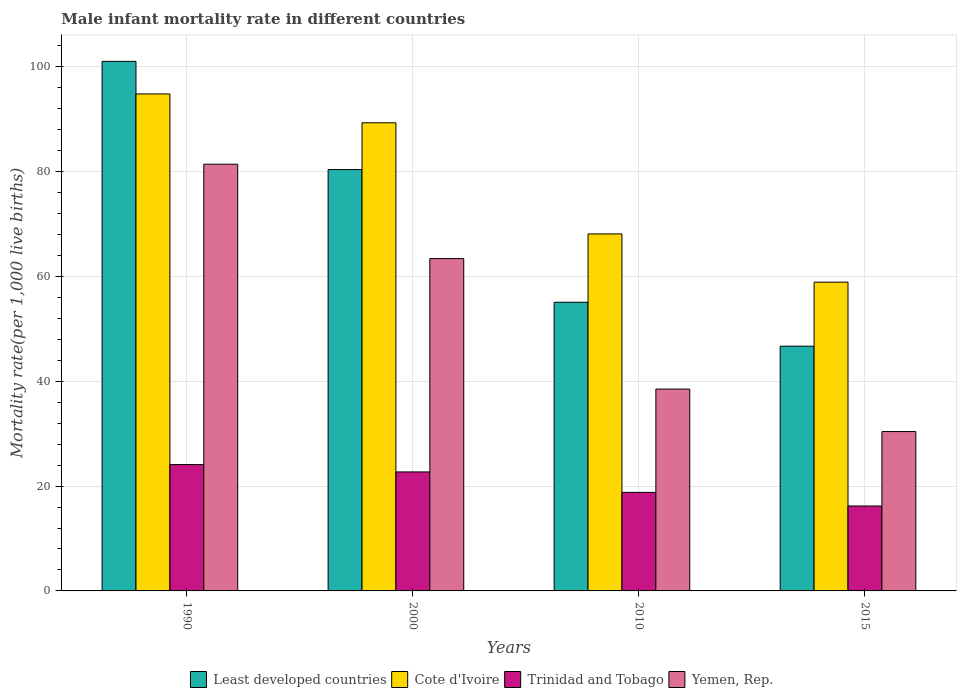How many different coloured bars are there?
Your response must be concise. 4. How many groups of bars are there?
Ensure brevity in your answer.  4. Are the number of bars per tick equal to the number of legend labels?
Your answer should be very brief. Yes. Are the number of bars on each tick of the X-axis equal?
Offer a very short reply. Yes. How many bars are there on the 4th tick from the right?
Give a very brief answer. 4. In how many cases, is the number of bars for a given year not equal to the number of legend labels?
Provide a short and direct response. 0. What is the male infant mortality rate in Cote d'Ivoire in 2010?
Your answer should be very brief. 68.1. Across all years, what is the maximum male infant mortality rate in Least developed countries?
Provide a short and direct response. 101.02. Across all years, what is the minimum male infant mortality rate in Cote d'Ivoire?
Provide a succinct answer. 58.9. In which year was the male infant mortality rate in Trinidad and Tobago maximum?
Offer a terse response. 1990. In which year was the male infant mortality rate in Yemen, Rep. minimum?
Ensure brevity in your answer.  2015. What is the total male infant mortality rate in Cote d'Ivoire in the graph?
Provide a succinct answer. 311.1. What is the difference between the male infant mortality rate in Trinidad and Tobago in 2000 and that in 2010?
Your answer should be compact. 3.9. What is the difference between the male infant mortality rate in Trinidad and Tobago in 2010 and the male infant mortality rate in Cote d'Ivoire in 2015?
Offer a terse response. -40.1. What is the average male infant mortality rate in Trinidad and Tobago per year?
Ensure brevity in your answer.  20.45. In the year 1990, what is the difference between the male infant mortality rate in Yemen, Rep. and male infant mortality rate in Trinidad and Tobago?
Offer a terse response. 57.3. In how many years, is the male infant mortality rate in Cote d'Ivoire greater than 64?
Keep it short and to the point. 3. What is the ratio of the male infant mortality rate in Least developed countries in 1990 to that in 2000?
Keep it short and to the point. 1.26. Is the difference between the male infant mortality rate in Yemen, Rep. in 2010 and 2015 greater than the difference between the male infant mortality rate in Trinidad and Tobago in 2010 and 2015?
Keep it short and to the point. Yes. What is the difference between the highest and the second highest male infant mortality rate in Trinidad and Tobago?
Your answer should be compact. 1.4. What is the difference between the highest and the lowest male infant mortality rate in Yemen, Rep.?
Offer a terse response. 51. Is the sum of the male infant mortality rate in Trinidad and Tobago in 2000 and 2015 greater than the maximum male infant mortality rate in Yemen, Rep. across all years?
Ensure brevity in your answer.  No. Is it the case that in every year, the sum of the male infant mortality rate in Yemen, Rep. and male infant mortality rate in Cote d'Ivoire is greater than the sum of male infant mortality rate in Least developed countries and male infant mortality rate in Trinidad and Tobago?
Offer a terse response. Yes. What does the 1st bar from the left in 2015 represents?
Make the answer very short. Least developed countries. What does the 1st bar from the right in 2015 represents?
Provide a short and direct response. Yemen, Rep. How many bars are there?
Your response must be concise. 16. Are all the bars in the graph horizontal?
Offer a terse response. No. How many years are there in the graph?
Provide a succinct answer. 4. What is the difference between two consecutive major ticks on the Y-axis?
Your answer should be compact. 20. Does the graph contain grids?
Provide a short and direct response. Yes. Where does the legend appear in the graph?
Your answer should be very brief. Bottom center. How are the legend labels stacked?
Offer a terse response. Horizontal. What is the title of the graph?
Your answer should be compact. Male infant mortality rate in different countries. Does "Zimbabwe" appear as one of the legend labels in the graph?
Offer a very short reply. No. What is the label or title of the Y-axis?
Provide a short and direct response. Mortality rate(per 1,0 live births). What is the Mortality rate(per 1,000 live births) of Least developed countries in 1990?
Keep it short and to the point. 101.02. What is the Mortality rate(per 1,000 live births) in Cote d'Ivoire in 1990?
Your answer should be very brief. 94.8. What is the Mortality rate(per 1,000 live births) in Trinidad and Tobago in 1990?
Provide a succinct answer. 24.1. What is the Mortality rate(per 1,000 live births) in Yemen, Rep. in 1990?
Your answer should be compact. 81.4. What is the Mortality rate(per 1,000 live births) of Least developed countries in 2000?
Your answer should be compact. 80.38. What is the Mortality rate(per 1,000 live births) in Cote d'Ivoire in 2000?
Make the answer very short. 89.3. What is the Mortality rate(per 1,000 live births) in Trinidad and Tobago in 2000?
Your answer should be compact. 22.7. What is the Mortality rate(per 1,000 live births) of Yemen, Rep. in 2000?
Give a very brief answer. 63.4. What is the Mortality rate(per 1,000 live births) of Least developed countries in 2010?
Ensure brevity in your answer.  55.07. What is the Mortality rate(per 1,000 live births) in Cote d'Ivoire in 2010?
Offer a terse response. 68.1. What is the Mortality rate(per 1,000 live births) in Yemen, Rep. in 2010?
Ensure brevity in your answer.  38.5. What is the Mortality rate(per 1,000 live births) of Least developed countries in 2015?
Give a very brief answer. 46.69. What is the Mortality rate(per 1,000 live births) of Cote d'Ivoire in 2015?
Provide a succinct answer. 58.9. What is the Mortality rate(per 1,000 live births) in Trinidad and Tobago in 2015?
Your answer should be very brief. 16.2. What is the Mortality rate(per 1,000 live births) of Yemen, Rep. in 2015?
Ensure brevity in your answer.  30.4. Across all years, what is the maximum Mortality rate(per 1,000 live births) in Least developed countries?
Give a very brief answer. 101.02. Across all years, what is the maximum Mortality rate(per 1,000 live births) of Cote d'Ivoire?
Provide a short and direct response. 94.8. Across all years, what is the maximum Mortality rate(per 1,000 live births) in Trinidad and Tobago?
Provide a succinct answer. 24.1. Across all years, what is the maximum Mortality rate(per 1,000 live births) in Yemen, Rep.?
Your response must be concise. 81.4. Across all years, what is the minimum Mortality rate(per 1,000 live births) in Least developed countries?
Give a very brief answer. 46.69. Across all years, what is the minimum Mortality rate(per 1,000 live births) in Cote d'Ivoire?
Your response must be concise. 58.9. Across all years, what is the minimum Mortality rate(per 1,000 live births) in Yemen, Rep.?
Keep it short and to the point. 30.4. What is the total Mortality rate(per 1,000 live births) in Least developed countries in the graph?
Offer a terse response. 283.15. What is the total Mortality rate(per 1,000 live births) in Cote d'Ivoire in the graph?
Your answer should be very brief. 311.1. What is the total Mortality rate(per 1,000 live births) in Trinidad and Tobago in the graph?
Provide a succinct answer. 81.8. What is the total Mortality rate(per 1,000 live births) in Yemen, Rep. in the graph?
Provide a succinct answer. 213.7. What is the difference between the Mortality rate(per 1,000 live births) in Least developed countries in 1990 and that in 2000?
Your response must be concise. 20.64. What is the difference between the Mortality rate(per 1,000 live births) in Trinidad and Tobago in 1990 and that in 2000?
Provide a short and direct response. 1.4. What is the difference between the Mortality rate(per 1,000 live births) in Least developed countries in 1990 and that in 2010?
Keep it short and to the point. 45.95. What is the difference between the Mortality rate(per 1,000 live births) of Cote d'Ivoire in 1990 and that in 2010?
Ensure brevity in your answer.  26.7. What is the difference between the Mortality rate(per 1,000 live births) in Trinidad and Tobago in 1990 and that in 2010?
Provide a succinct answer. 5.3. What is the difference between the Mortality rate(per 1,000 live births) in Yemen, Rep. in 1990 and that in 2010?
Ensure brevity in your answer.  42.9. What is the difference between the Mortality rate(per 1,000 live births) of Least developed countries in 1990 and that in 2015?
Keep it short and to the point. 54.33. What is the difference between the Mortality rate(per 1,000 live births) in Cote d'Ivoire in 1990 and that in 2015?
Provide a succinct answer. 35.9. What is the difference between the Mortality rate(per 1,000 live births) in Trinidad and Tobago in 1990 and that in 2015?
Ensure brevity in your answer.  7.9. What is the difference between the Mortality rate(per 1,000 live births) in Least developed countries in 2000 and that in 2010?
Make the answer very short. 25.31. What is the difference between the Mortality rate(per 1,000 live births) of Cote d'Ivoire in 2000 and that in 2010?
Ensure brevity in your answer.  21.2. What is the difference between the Mortality rate(per 1,000 live births) of Yemen, Rep. in 2000 and that in 2010?
Make the answer very short. 24.9. What is the difference between the Mortality rate(per 1,000 live births) of Least developed countries in 2000 and that in 2015?
Your answer should be very brief. 33.69. What is the difference between the Mortality rate(per 1,000 live births) of Cote d'Ivoire in 2000 and that in 2015?
Your answer should be compact. 30.4. What is the difference between the Mortality rate(per 1,000 live births) in Trinidad and Tobago in 2000 and that in 2015?
Ensure brevity in your answer.  6.5. What is the difference between the Mortality rate(per 1,000 live births) in Least developed countries in 2010 and that in 2015?
Give a very brief answer. 8.38. What is the difference between the Mortality rate(per 1,000 live births) of Cote d'Ivoire in 2010 and that in 2015?
Your answer should be compact. 9.2. What is the difference between the Mortality rate(per 1,000 live births) of Trinidad and Tobago in 2010 and that in 2015?
Your answer should be compact. 2.6. What is the difference between the Mortality rate(per 1,000 live births) in Least developed countries in 1990 and the Mortality rate(per 1,000 live births) in Cote d'Ivoire in 2000?
Provide a succinct answer. 11.72. What is the difference between the Mortality rate(per 1,000 live births) in Least developed countries in 1990 and the Mortality rate(per 1,000 live births) in Trinidad and Tobago in 2000?
Your answer should be very brief. 78.32. What is the difference between the Mortality rate(per 1,000 live births) in Least developed countries in 1990 and the Mortality rate(per 1,000 live births) in Yemen, Rep. in 2000?
Your answer should be very brief. 37.62. What is the difference between the Mortality rate(per 1,000 live births) in Cote d'Ivoire in 1990 and the Mortality rate(per 1,000 live births) in Trinidad and Tobago in 2000?
Ensure brevity in your answer.  72.1. What is the difference between the Mortality rate(per 1,000 live births) of Cote d'Ivoire in 1990 and the Mortality rate(per 1,000 live births) of Yemen, Rep. in 2000?
Give a very brief answer. 31.4. What is the difference between the Mortality rate(per 1,000 live births) of Trinidad and Tobago in 1990 and the Mortality rate(per 1,000 live births) of Yemen, Rep. in 2000?
Keep it short and to the point. -39.3. What is the difference between the Mortality rate(per 1,000 live births) of Least developed countries in 1990 and the Mortality rate(per 1,000 live births) of Cote d'Ivoire in 2010?
Provide a short and direct response. 32.92. What is the difference between the Mortality rate(per 1,000 live births) of Least developed countries in 1990 and the Mortality rate(per 1,000 live births) of Trinidad and Tobago in 2010?
Make the answer very short. 82.22. What is the difference between the Mortality rate(per 1,000 live births) of Least developed countries in 1990 and the Mortality rate(per 1,000 live births) of Yemen, Rep. in 2010?
Your response must be concise. 62.52. What is the difference between the Mortality rate(per 1,000 live births) in Cote d'Ivoire in 1990 and the Mortality rate(per 1,000 live births) in Trinidad and Tobago in 2010?
Provide a short and direct response. 76. What is the difference between the Mortality rate(per 1,000 live births) of Cote d'Ivoire in 1990 and the Mortality rate(per 1,000 live births) of Yemen, Rep. in 2010?
Your answer should be very brief. 56.3. What is the difference between the Mortality rate(per 1,000 live births) of Trinidad and Tobago in 1990 and the Mortality rate(per 1,000 live births) of Yemen, Rep. in 2010?
Give a very brief answer. -14.4. What is the difference between the Mortality rate(per 1,000 live births) of Least developed countries in 1990 and the Mortality rate(per 1,000 live births) of Cote d'Ivoire in 2015?
Provide a short and direct response. 42.12. What is the difference between the Mortality rate(per 1,000 live births) in Least developed countries in 1990 and the Mortality rate(per 1,000 live births) in Trinidad and Tobago in 2015?
Offer a terse response. 84.82. What is the difference between the Mortality rate(per 1,000 live births) of Least developed countries in 1990 and the Mortality rate(per 1,000 live births) of Yemen, Rep. in 2015?
Your answer should be very brief. 70.62. What is the difference between the Mortality rate(per 1,000 live births) of Cote d'Ivoire in 1990 and the Mortality rate(per 1,000 live births) of Trinidad and Tobago in 2015?
Offer a very short reply. 78.6. What is the difference between the Mortality rate(per 1,000 live births) in Cote d'Ivoire in 1990 and the Mortality rate(per 1,000 live births) in Yemen, Rep. in 2015?
Offer a terse response. 64.4. What is the difference between the Mortality rate(per 1,000 live births) of Least developed countries in 2000 and the Mortality rate(per 1,000 live births) of Cote d'Ivoire in 2010?
Your response must be concise. 12.28. What is the difference between the Mortality rate(per 1,000 live births) of Least developed countries in 2000 and the Mortality rate(per 1,000 live births) of Trinidad and Tobago in 2010?
Your response must be concise. 61.58. What is the difference between the Mortality rate(per 1,000 live births) of Least developed countries in 2000 and the Mortality rate(per 1,000 live births) of Yemen, Rep. in 2010?
Your answer should be very brief. 41.88. What is the difference between the Mortality rate(per 1,000 live births) of Cote d'Ivoire in 2000 and the Mortality rate(per 1,000 live births) of Trinidad and Tobago in 2010?
Make the answer very short. 70.5. What is the difference between the Mortality rate(per 1,000 live births) of Cote d'Ivoire in 2000 and the Mortality rate(per 1,000 live births) of Yemen, Rep. in 2010?
Offer a terse response. 50.8. What is the difference between the Mortality rate(per 1,000 live births) in Trinidad and Tobago in 2000 and the Mortality rate(per 1,000 live births) in Yemen, Rep. in 2010?
Give a very brief answer. -15.8. What is the difference between the Mortality rate(per 1,000 live births) in Least developed countries in 2000 and the Mortality rate(per 1,000 live births) in Cote d'Ivoire in 2015?
Offer a terse response. 21.48. What is the difference between the Mortality rate(per 1,000 live births) of Least developed countries in 2000 and the Mortality rate(per 1,000 live births) of Trinidad and Tobago in 2015?
Ensure brevity in your answer.  64.18. What is the difference between the Mortality rate(per 1,000 live births) of Least developed countries in 2000 and the Mortality rate(per 1,000 live births) of Yemen, Rep. in 2015?
Ensure brevity in your answer.  49.98. What is the difference between the Mortality rate(per 1,000 live births) of Cote d'Ivoire in 2000 and the Mortality rate(per 1,000 live births) of Trinidad and Tobago in 2015?
Give a very brief answer. 73.1. What is the difference between the Mortality rate(per 1,000 live births) of Cote d'Ivoire in 2000 and the Mortality rate(per 1,000 live births) of Yemen, Rep. in 2015?
Make the answer very short. 58.9. What is the difference between the Mortality rate(per 1,000 live births) of Trinidad and Tobago in 2000 and the Mortality rate(per 1,000 live births) of Yemen, Rep. in 2015?
Make the answer very short. -7.7. What is the difference between the Mortality rate(per 1,000 live births) in Least developed countries in 2010 and the Mortality rate(per 1,000 live births) in Cote d'Ivoire in 2015?
Keep it short and to the point. -3.83. What is the difference between the Mortality rate(per 1,000 live births) of Least developed countries in 2010 and the Mortality rate(per 1,000 live births) of Trinidad and Tobago in 2015?
Ensure brevity in your answer.  38.87. What is the difference between the Mortality rate(per 1,000 live births) in Least developed countries in 2010 and the Mortality rate(per 1,000 live births) in Yemen, Rep. in 2015?
Your answer should be very brief. 24.67. What is the difference between the Mortality rate(per 1,000 live births) in Cote d'Ivoire in 2010 and the Mortality rate(per 1,000 live births) in Trinidad and Tobago in 2015?
Make the answer very short. 51.9. What is the difference between the Mortality rate(per 1,000 live births) in Cote d'Ivoire in 2010 and the Mortality rate(per 1,000 live births) in Yemen, Rep. in 2015?
Your response must be concise. 37.7. What is the average Mortality rate(per 1,000 live births) of Least developed countries per year?
Provide a succinct answer. 70.79. What is the average Mortality rate(per 1,000 live births) of Cote d'Ivoire per year?
Your answer should be compact. 77.78. What is the average Mortality rate(per 1,000 live births) in Trinidad and Tobago per year?
Offer a very short reply. 20.45. What is the average Mortality rate(per 1,000 live births) in Yemen, Rep. per year?
Offer a terse response. 53.42. In the year 1990, what is the difference between the Mortality rate(per 1,000 live births) in Least developed countries and Mortality rate(per 1,000 live births) in Cote d'Ivoire?
Offer a terse response. 6.22. In the year 1990, what is the difference between the Mortality rate(per 1,000 live births) of Least developed countries and Mortality rate(per 1,000 live births) of Trinidad and Tobago?
Your answer should be compact. 76.92. In the year 1990, what is the difference between the Mortality rate(per 1,000 live births) of Least developed countries and Mortality rate(per 1,000 live births) of Yemen, Rep.?
Provide a short and direct response. 19.62. In the year 1990, what is the difference between the Mortality rate(per 1,000 live births) in Cote d'Ivoire and Mortality rate(per 1,000 live births) in Trinidad and Tobago?
Provide a succinct answer. 70.7. In the year 1990, what is the difference between the Mortality rate(per 1,000 live births) in Cote d'Ivoire and Mortality rate(per 1,000 live births) in Yemen, Rep.?
Provide a succinct answer. 13.4. In the year 1990, what is the difference between the Mortality rate(per 1,000 live births) in Trinidad and Tobago and Mortality rate(per 1,000 live births) in Yemen, Rep.?
Ensure brevity in your answer.  -57.3. In the year 2000, what is the difference between the Mortality rate(per 1,000 live births) of Least developed countries and Mortality rate(per 1,000 live births) of Cote d'Ivoire?
Ensure brevity in your answer.  -8.92. In the year 2000, what is the difference between the Mortality rate(per 1,000 live births) of Least developed countries and Mortality rate(per 1,000 live births) of Trinidad and Tobago?
Provide a short and direct response. 57.68. In the year 2000, what is the difference between the Mortality rate(per 1,000 live births) of Least developed countries and Mortality rate(per 1,000 live births) of Yemen, Rep.?
Provide a succinct answer. 16.98. In the year 2000, what is the difference between the Mortality rate(per 1,000 live births) in Cote d'Ivoire and Mortality rate(per 1,000 live births) in Trinidad and Tobago?
Your answer should be very brief. 66.6. In the year 2000, what is the difference between the Mortality rate(per 1,000 live births) of Cote d'Ivoire and Mortality rate(per 1,000 live births) of Yemen, Rep.?
Offer a very short reply. 25.9. In the year 2000, what is the difference between the Mortality rate(per 1,000 live births) of Trinidad and Tobago and Mortality rate(per 1,000 live births) of Yemen, Rep.?
Give a very brief answer. -40.7. In the year 2010, what is the difference between the Mortality rate(per 1,000 live births) in Least developed countries and Mortality rate(per 1,000 live births) in Cote d'Ivoire?
Provide a short and direct response. -13.03. In the year 2010, what is the difference between the Mortality rate(per 1,000 live births) of Least developed countries and Mortality rate(per 1,000 live births) of Trinidad and Tobago?
Make the answer very short. 36.27. In the year 2010, what is the difference between the Mortality rate(per 1,000 live births) of Least developed countries and Mortality rate(per 1,000 live births) of Yemen, Rep.?
Your answer should be compact. 16.57. In the year 2010, what is the difference between the Mortality rate(per 1,000 live births) of Cote d'Ivoire and Mortality rate(per 1,000 live births) of Trinidad and Tobago?
Ensure brevity in your answer.  49.3. In the year 2010, what is the difference between the Mortality rate(per 1,000 live births) in Cote d'Ivoire and Mortality rate(per 1,000 live births) in Yemen, Rep.?
Keep it short and to the point. 29.6. In the year 2010, what is the difference between the Mortality rate(per 1,000 live births) in Trinidad and Tobago and Mortality rate(per 1,000 live births) in Yemen, Rep.?
Ensure brevity in your answer.  -19.7. In the year 2015, what is the difference between the Mortality rate(per 1,000 live births) of Least developed countries and Mortality rate(per 1,000 live births) of Cote d'Ivoire?
Keep it short and to the point. -12.21. In the year 2015, what is the difference between the Mortality rate(per 1,000 live births) in Least developed countries and Mortality rate(per 1,000 live births) in Trinidad and Tobago?
Provide a succinct answer. 30.49. In the year 2015, what is the difference between the Mortality rate(per 1,000 live births) of Least developed countries and Mortality rate(per 1,000 live births) of Yemen, Rep.?
Your answer should be compact. 16.29. In the year 2015, what is the difference between the Mortality rate(per 1,000 live births) of Cote d'Ivoire and Mortality rate(per 1,000 live births) of Trinidad and Tobago?
Ensure brevity in your answer.  42.7. What is the ratio of the Mortality rate(per 1,000 live births) in Least developed countries in 1990 to that in 2000?
Give a very brief answer. 1.26. What is the ratio of the Mortality rate(per 1,000 live births) of Cote d'Ivoire in 1990 to that in 2000?
Ensure brevity in your answer.  1.06. What is the ratio of the Mortality rate(per 1,000 live births) of Trinidad and Tobago in 1990 to that in 2000?
Provide a short and direct response. 1.06. What is the ratio of the Mortality rate(per 1,000 live births) of Yemen, Rep. in 1990 to that in 2000?
Offer a very short reply. 1.28. What is the ratio of the Mortality rate(per 1,000 live births) in Least developed countries in 1990 to that in 2010?
Your response must be concise. 1.83. What is the ratio of the Mortality rate(per 1,000 live births) of Cote d'Ivoire in 1990 to that in 2010?
Your answer should be very brief. 1.39. What is the ratio of the Mortality rate(per 1,000 live births) of Trinidad and Tobago in 1990 to that in 2010?
Keep it short and to the point. 1.28. What is the ratio of the Mortality rate(per 1,000 live births) in Yemen, Rep. in 1990 to that in 2010?
Keep it short and to the point. 2.11. What is the ratio of the Mortality rate(per 1,000 live births) of Least developed countries in 1990 to that in 2015?
Give a very brief answer. 2.16. What is the ratio of the Mortality rate(per 1,000 live births) of Cote d'Ivoire in 1990 to that in 2015?
Give a very brief answer. 1.61. What is the ratio of the Mortality rate(per 1,000 live births) of Trinidad and Tobago in 1990 to that in 2015?
Your response must be concise. 1.49. What is the ratio of the Mortality rate(per 1,000 live births) of Yemen, Rep. in 1990 to that in 2015?
Ensure brevity in your answer.  2.68. What is the ratio of the Mortality rate(per 1,000 live births) in Least developed countries in 2000 to that in 2010?
Your response must be concise. 1.46. What is the ratio of the Mortality rate(per 1,000 live births) in Cote d'Ivoire in 2000 to that in 2010?
Your answer should be compact. 1.31. What is the ratio of the Mortality rate(per 1,000 live births) in Trinidad and Tobago in 2000 to that in 2010?
Provide a succinct answer. 1.21. What is the ratio of the Mortality rate(per 1,000 live births) of Yemen, Rep. in 2000 to that in 2010?
Your answer should be compact. 1.65. What is the ratio of the Mortality rate(per 1,000 live births) in Least developed countries in 2000 to that in 2015?
Your response must be concise. 1.72. What is the ratio of the Mortality rate(per 1,000 live births) in Cote d'Ivoire in 2000 to that in 2015?
Make the answer very short. 1.52. What is the ratio of the Mortality rate(per 1,000 live births) in Trinidad and Tobago in 2000 to that in 2015?
Ensure brevity in your answer.  1.4. What is the ratio of the Mortality rate(per 1,000 live births) of Yemen, Rep. in 2000 to that in 2015?
Offer a terse response. 2.09. What is the ratio of the Mortality rate(per 1,000 live births) of Least developed countries in 2010 to that in 2015?
Provide a short and direct response. 1.18. What is the ratio of the Mortality rate(per 1,000 live births) in Cote d'Ivoire in 2010 to that in 2015?
Offer a very short reply. 1.16. What is the ratio of the Mortality rate(per 1,000 live births) of Trinidad and Tobago in 2010 to that in 2015?
Keep it short and to the point. 1.16. What is the ratio of the Mortality rate(per 1,000 live births) in Yemen, Rep. in 2010 to that in 2015?
Your answer should be very brief. 1.27. What is the difference between the highest and the second highest Mortality rate(per 1,000 live births) of Least developed countries?
Ensure brevity in your answer.  20.64. What is the difference between the highest and the second highest Mortality rate(per 1,000 live births) in Yemen, Rep.?
Your response must be concise. 18. What is the difference between the highest and the lowest Mortality rate(per 1,000 live births) in Least developed countries?
Offer a very short reply. 54.33. What is the difference between the highest and the lowest Mortality rate(per 1,000 live births) of Cote d'Ivoire?
Provide a short and direct response. 35.9. What is the difference between the highest and the lowest Mortality rate(per 1,000 live births) in Trinidad and Tobago?
Offer a very short reply. 7.9. What is the difference between the highest and the lowest Mortality rate(per 1,000 live births) of Yemen, Rep.?
Ensure brevity in your answer.  51. 